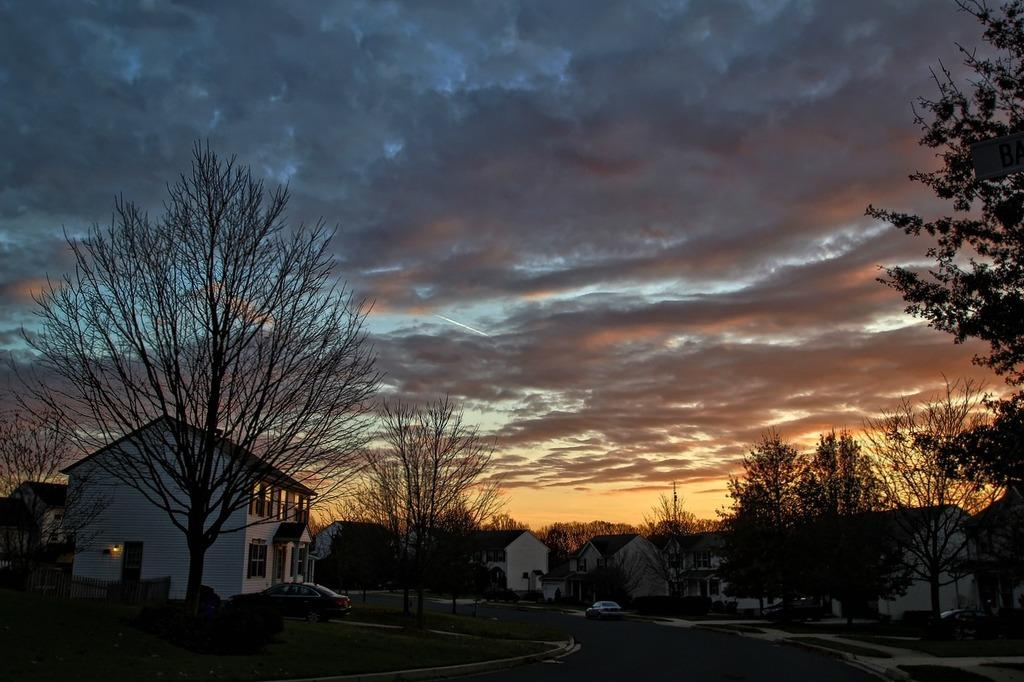What type of structures can be seen in the image? There are buildings in the image. What is happening on the road in the image? Motor vehicles are present on the road in the image. What type of fencing can be seen in the image? Wooden fences are visible in the image. What type of vegetation is present in the image? Trees are present in the image. What is visible in the background of the image? The sky is visible in the background of the image. What can be seen in the sky in the background of the image? Clouds are present in the sky in the background of the image. What is the process of the story being told in the image? There is no story being told in the image, as it is a photograph of a scene with buildings, motor vehicles, wooden fences, trees, and clouds in the sky. How many trucks are visible in the image? There are no trucks mentioned in the provided facts, so we cannot determine the number of trucks in the image. 